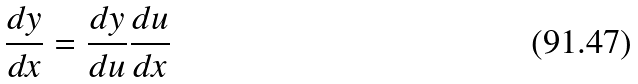Convert formula to latex. <formula><loc_0><loc_0><loc_500><loc_500>\frac { d y } { d x } = \frac { d y } { d u } \frac { d u } { d x }</formula> 